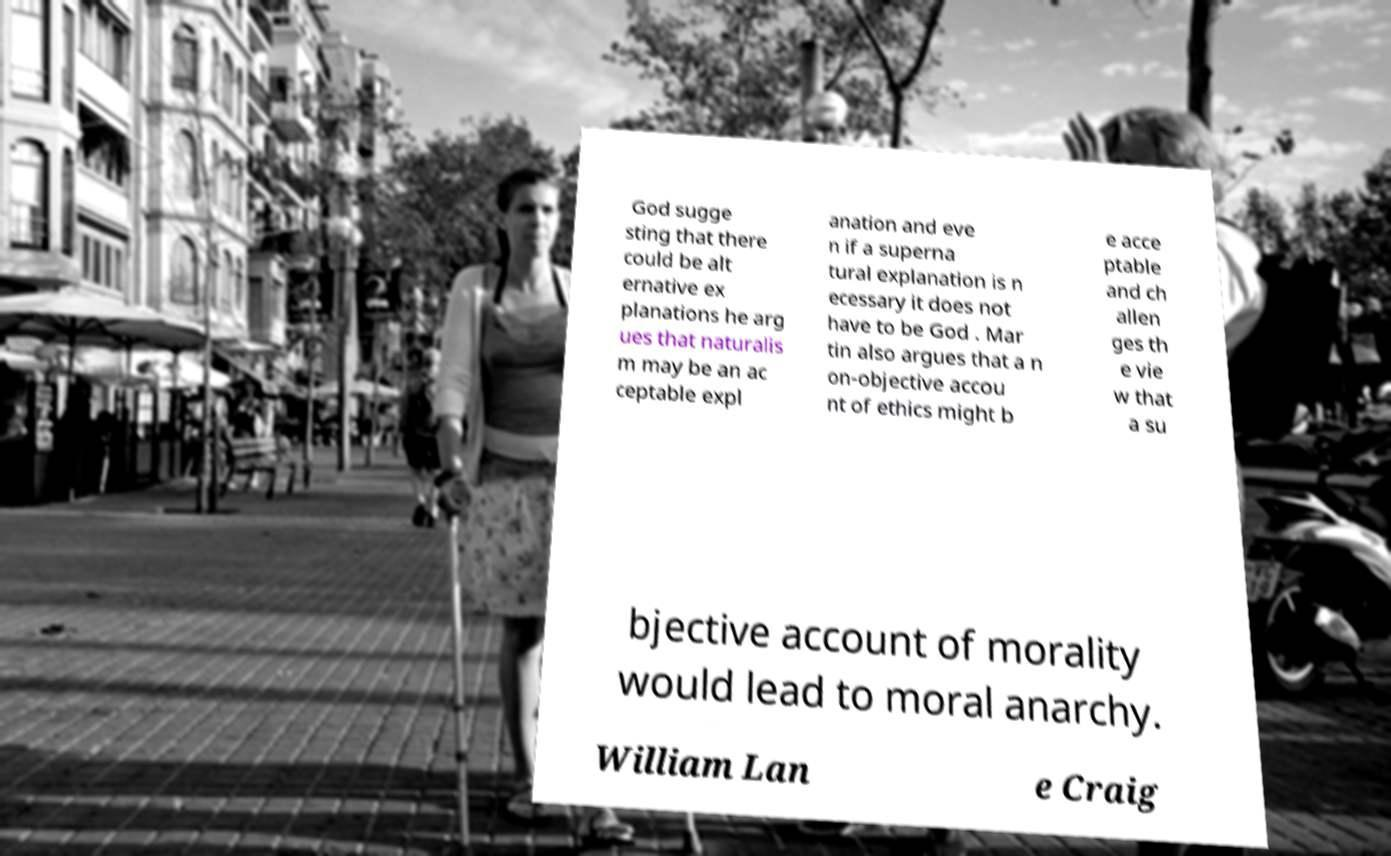There's text embedded in this image that I need extracted. Can you transcribe it verbatim? God sugge sting that there could be alt ernative ex planations he arg ues that naturalis m may be an ac ceptable expl anation and eve n if a superna tural explanation is n ecessary it does not have to be God . Mar tin also argues that a n on-objective accou nt of ethics might b e acce ptable and ch allen ges th e vie w that a su bjective account of morality would lead to moral anarchy. William Lan e Craig 